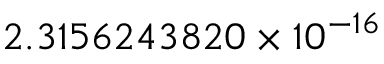Convert formula to latex. <formula><loc_0><loc_0><loc_500><loc_500>2 . 3 1 5 6 2 4 3 8 2 0 \times 1 0 ^ { - 1 6 }</formula> 